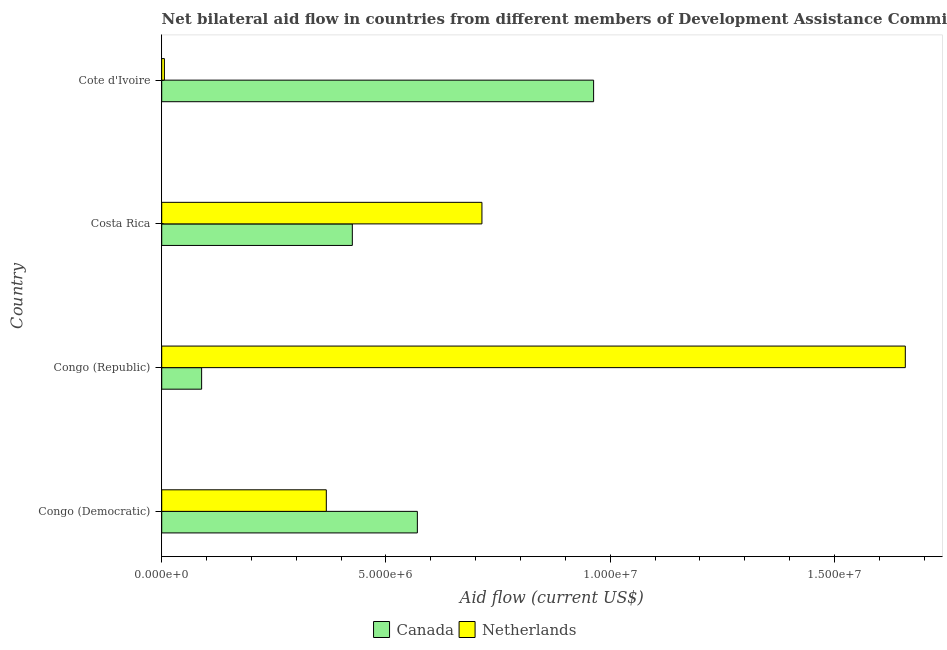How many different coloured bars are there?
Give a very brief answer. 2. Are the number of bars per tick equal to the number of legend labels?
Provide a succinct answer. Yes. Are the number of bars on each tick of the Y-axis equal?
Offer a terse response. Yes. How many bars are there on the 4th tick from the bottom?
Keep it short and to the point. 2. What is the label of the 1st group of bars from the top?
Give a very brief answer. Cote d'Ivoire. In how many cases, is the number of bars for a given country not equal to the number of legend labels?
Ensure brevity in your answer.  0. What is the amount of aid given by canada in Congo (Democratic)?
Provide a succinct answer. 5.70e+06. Across all countries, what is the maximum amount of aid given by netherlands?
Provide a succinct answer. 1.66e+07. Across all countries, what is the minimum amount of aid given by netherlands?
Provide a succinct answer. 6.00e+04. In which country was the amount of aid given by canada maximum?
Keep it short and to the point. Cote d'Ivoire. In which country was the amount of aid given by canada minimum?
Your answer should be compact. Congo (Republic). What is the total amount of aid given by netherlands in the graph?
Your answer should be compact. 2.74e+07. What is the difference between the amount of aid given by canada in Congo (Democratic) and that in Cote d'Ivoire?
Keep it short and to the point. -3.93e+06. What is the difference between the amount of aid given by canada in Congo (Democratic) and the amount of aid given by netherlands in Cote d'Ivoire?
Your answer should be compact. 5.64e+06. What is the average amount of aid given by netherlands per country?
Your answer should be compact. 6.86e+06. What is the difference between the amount of aid given by canada and amount of aid given by netherlands in Congo (Republic)?
Provide a short and direct response. -1.57e+07. In how many countries, is the amount of aid given by netherlands greater than 14000000 US$?
Provide a short and direct response. 1. What is the ratio of the amount of aid given by canada in Congo (Democratic) to that in Costa Rica?
Your answer should be very brief. 1.34. Is the difference between the amount of aid given by netherlands in Congo (Democratic) and Cote d'Ivoire greater than the difference between the amount of aid given by canada in Congo (Democratic) and Cote d'Ivoire?
Ensure brevity in your answer.  Yes. What is the difference between the highest and the second highest amount of aid given by netherlands?
Your answer should be compact. 9.44e+06. What is the difference between the highest and the lowest amount of aid given by netherlands?
Your response must be concise. 1.65e+07. In how many countries, is the amount of aid given by netherlands greater than the average amount of aid given by netherlands taken over all countries?
Make the answer very short. 2. How many bars are there?
Ensure brevity in your answer.  8. Are all the bars in the graph horizontal?
Ensure brevity in your answer.  Yes. Are the values on the major ticks of X-axis written in scientific E-notation?
Provide a short and direct response. Yes. Does the graph contain any zero values?
Keep it short and to the point. No. How many legend labels are there?
Give a very brief answer. 2. How are the legend labels stacked?
Give a very brief answer. Horizontal. What is the title of the graph?
Ensure brevity in your answer.  Net bilateral aid flow in countries from different members of Development Assistance Committee. What is the Aid flow (current US$) in Canada in Congo (Democratic)?
Your response must be concise. 5.70e+06. What is the Aid flow (current US$) in Netherlands in Congo (Democratic)?
Offer a very short reply. 3.67e+06. What is the Aid flow (current US$) in Canada in Congo (Republic)?
Provide a succinct answer. 8.90e+05. What is the Aid flow (current US$) in Netherlands in Congo (Republic)?
Your response must be concise. 1.66e+07. What is the Aid flow (current US$) in Canada in Costa Rica?
Ensure brevity in your answer.  4.25e+06. What is the Aid flow (current US$) in Netherlands in Costa Rica?
Provide a short and direct response. 7.14e+06. What is the Aid flow (current US$) of Canada in Cote d'Ivoire?
Provide a short and direct response. 9.63e+06. Across all countries, what is the maximum Aid flow (current US$) in Canada?
Provide a succinct answer. 9.63e+06. Across all countries, what is the maximum Aid flow (current US$) in Netherlands?
Provide a short and direct response. 1.66e+07. Across all countries, what is the minimum Aid flow (current US$) in Canada?
Keep it short and to the point. 8.90e+05. Across all countries, what is the minimum Aid flow (current US$) of Netherlands?
Your response must be concise. 6.00e+04. What is the total Aid flow (current US$) in Canada in the graph?
Ensure brevity in your answer.  2.05e+07. What is the total Aid flow (current US$) in Netherlands in the graph?
Keep it short and to the point. 2.74e+07. What is the difference between the Aid flow (current US$) of Canada in Congo (Democratic) and that in Congo (Republic)?
Ensure brevity in your answer.  4.81e+06. What is the difference between the Aid flow (current US$) of Netherlands in Congo (Democratic) and that in Congo (Republic)?
Provide a succinct answer. -1.29e+07. What is the difference between the Aid flow (current US$) of Canada in Congo (Democratic) and that in Costa Rica?
Your answer should be very brief. 1.45e+06. What is the difference between the Aid flow (current US$) in Netherlands in Congo (Democratic) and that in Costa Rica?
Provide a succinct answer. -3.47e+06. What is the difference between the Aid flow (current US$) of Canada in Congo (Democratic) and that in Cote d'Ivoire?
Offer a very short reply. -3.93e+06. What is the difference between the Aid flow (current US$) in Netherlands in Congo (Democratic) and that in Cote d'Ivoire?
Ensure brevity in your answer.  3.61e+06. What is the difference between the Aid flow (current US$) of Canada in Congo (Republic) and that in Costa Rica?
Keep it short and to the point. -3.36e+06. What is the difference between the Aid flow (current US$) of Netherlands in Congo (Republic) and that in Costa Rica?
Keep it short and to the point. 9.44e+06. What is the difference between the Aid flow (current US$) of Canada in Congo (Republic) and that in Cote d'Ivoire?
Your answer should be very brief. -8.74e+06. What is the difference between the Aid flow (current US$) in Netherlands in Congo (Republic) and that in Cote d'Ivoire?
Your response must be concise. 1.65e+07. What is the difference between the Aid flow (current US$) in Canada in Costa Rica and that in Cote d'Ivoire?
Provide a succinct answer. -5.38e+06. What is the difference between the Aid flow (current US$) of Netherlands in Costa Rica and that in Cote d'Ivoire?
Ensure brevity in your answer.  7.08e+06. What is the difference between the Aid flow (current US$) in Canada in Congo (Democratic) and the Aid flow (current US$) in Netherlands in Congo (Republic)?
Your answer should be very brief. -1.09e+07. What is the difference between the Aid flow (current US$) of Canada in Congo (Democratic) and the Aid flow (current US$) of Netherlands in Costa Rica?
Provide a succinct answer. -1.44e+06. What is the difference between the Aid flow (current US$) of Canada in Congo (Democratic) and the Aid flow (current US$) of Netherlands in Cote d'Ivoire?
Your answer should be very brief. 5.64e+06. What is the difference between the Aid flow (current US$) of Canada in Congo (Republic) and the Aid flow (current US$) of Netherlands in Costa Rica?
Ensure brevity in your answer.  -6.25e+06. What is the difference between the Aid flow (current US$) of Canada in Congo (Republic) and the Aid flow (current US$) of Netherlands in Cote d'Ivoire?
Your answer should be compact. 8.30e+05. What is the difference between the Aid flow (current US$) of Canada in Costa Rica and the Aid flow (current US$) of Netherlands in Cote d'Ivoire?
Keep it short and to the point. 4.19e+06. What is the average Aid flow (current US$) of Canada per country?
Your answer should be very brief. 5.12e+06. What is the average Aid flow (current US$) in Netherlands per country?
Offer a very short reply. 6.86e+06. What is the difference between the Aid flow (current US$) in Canada and Aid flow (current US$) in Netherlands in Congo (Democratic)?
Ensure brevity in your answer.  2.03e+06. What is the difference between the Aid flow (current US$) of Canada and Aid flow (current US$) of Netherlands in Congo (Republic)?
Make the answer very short. -1.57e+07. What is the difference between the Aid flow (current US$) in Canada and Aid flow (current US$) in Netherlands in Costa Rica?
Your response must be concise. -2.89e+06. What is the difference between the Aid flow (current US$) of Canada and Aid flow (current US$) of Netherlands in Cote d'Ivoire?
Keep it short and to the point. 9.57e+06. What is the ratio of the Aid flow (current US$) in Canada in Congo (Democratic) to that in Congo (Republic)?
Provide a short and direct response. 6.4. What is the ratio of the Aid flow (current US$) in Netherlands in Congo (Democratic) to that in Congo (Republic)?
Your response must be concise. 0.22. What is the ratio of the Aid flow (current US$) of Canada in Congo (Democratic) to that in Costa Rica?
Give a very brief answer. 1.34. What is the ratio of the Aid flow (current US$) of Netherlands in Congo (Democratic) to that in Costa Rica?
Ensure brevity in your answer.  0.51. What is the ratio of the Aid flow (current US$) in Canada in Congo (Democratic) to that in Cote d'Ivoire?
Keep it short and to the point. 0.59. What is the ratio of the Aid flow (current US$) of Netherlands in Congo (Democratic) to that in Cote d'Ivoire?
Offer a terse response. 61.17. What is the ratio of the Aid flow (current US$) of Canada in Congo (Republic) to that in Costa Rica?
Provide a short and direct response. 0.21. What is the ratio of the Aid flow (current US$) in Netherlands in Congo (Republic) to that in Costa Rica?
Your answer should be compact. 2.32. What is the ratio of the Aid flow (current US$) of Canada in Congo (Republic) to that in Cote d'Ivoire?
Keep it short and to the point. 0.09. What is the ratio of the Aid flow (current US$) of Netherlands in Congo (Republic) to that in Cote d'Ivoire?
Your response must be concise. 276.33. What is the ratio of the Aid flow (current US$) in Canada in Costa Rica to that in Cote d'Ivoire?
Your response must be concise. 0.44. What is the ratio of the Aid flow (current US$) in Netherlands in Costa Rica to that in Cote d'Ivoire?
Your answer should be compact. 119. What is the difference between the highest and the second highest Aid flow (current US$) of Canada?
Ensure brevity in your answer.  3.93e+06. What is the difference between the highest and the second highest Aid flow (current US$) of Netherlands?
Your response must be concise. 9.44e+06. What is the difference between the highest and the lowest Aid flow (current US$) of Canada?
Provide a short and direct response. 8.74e+06. What is the difference between the highest and the lowest Aid flow (current US$) of Netherlands?
Your answer should be very brief. 1.65e+07. 